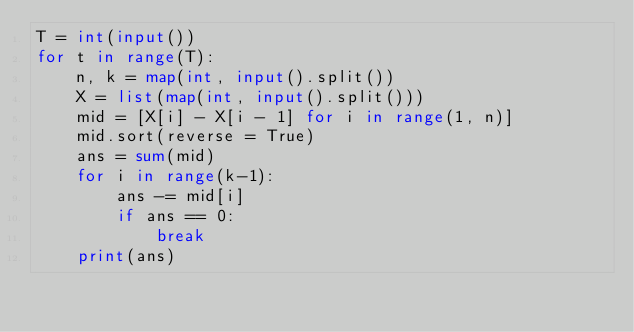<code> <loc_0><loc_0><loc_500><loc_500><_Python_>T = int(input())
for t in range(T):
    n, k = map(int, input().split())
    X = list(map(int, input().split()))
    mid = [X[i] - X[i - 1] for i in range(1, n)]
    mid.sort(reverse = True)
    ans = sum(mid)
    for i in range(k-1):
        ans -= mid[i]
        if ans == 0:
            break
    print(ans)
</code> 